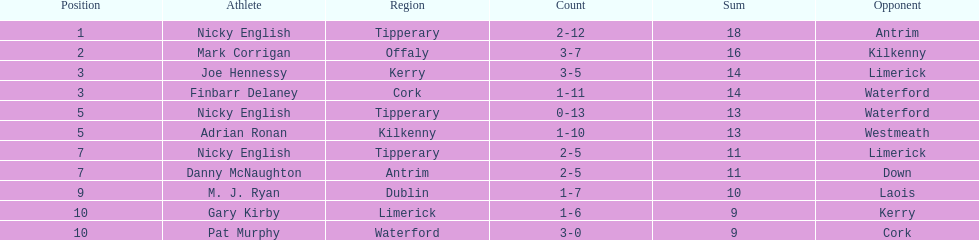How many people are on the list? 9. 